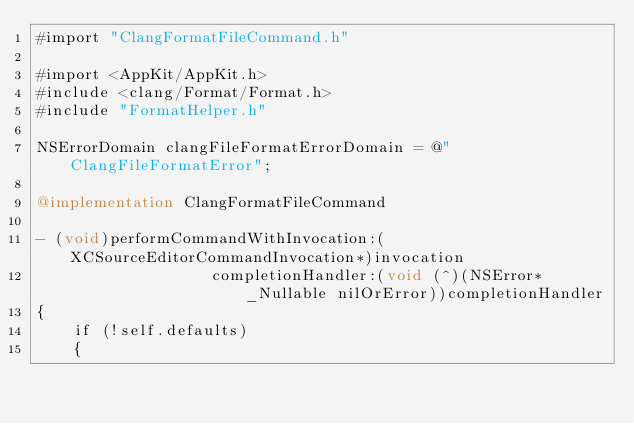Convert code to text. <code><loc_0><loc_0><loc_500><loc_500><_ObjectiveC_>#import "ClangFormatFileCommand.h"

#import <AppKit/AppKit.h>
#include <clang/Format/Format.h>
#include "FormatHelper.h"

NSErrorDomain clangFileFormatErrorDomain = @"ClangFileFormatError";

@implementation ClangFormatFileCommand

- (void)performCommandWithInvocation:(XCSourceEditorCommandInvocation*)invocation
                   completionHandler:(void (^)(NSError* _Nullable nilOrError))completionHandler
{
    if (!self.defaults)
    {</code> 